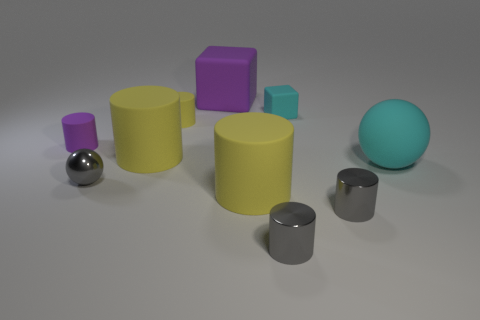Subtract all yellow cylinders. How many were subtracted if there are1yellow cylinders left? 2 Subtract all gray shiny cylinders. How many cylinders are left? 4 Subtract all cyan blocks. How many blocks are left? 1 Subtract 1 cylinders. How many cylinders are left? 5 Subtract all balls. How many objects are left? 8 Add 4 large cylinders. How many large cylinders are left? 6 Add 1 big yellow rubber objects. How many big yellow rubber objects exist? 3 Subtract 0 yellow blocks. How many objects are left? 10 Subtract all brown spheres. Subtract all blue cubes. How many spheres are left? 2 Subtract all brown cylinders. How many purple balls are left? 0 